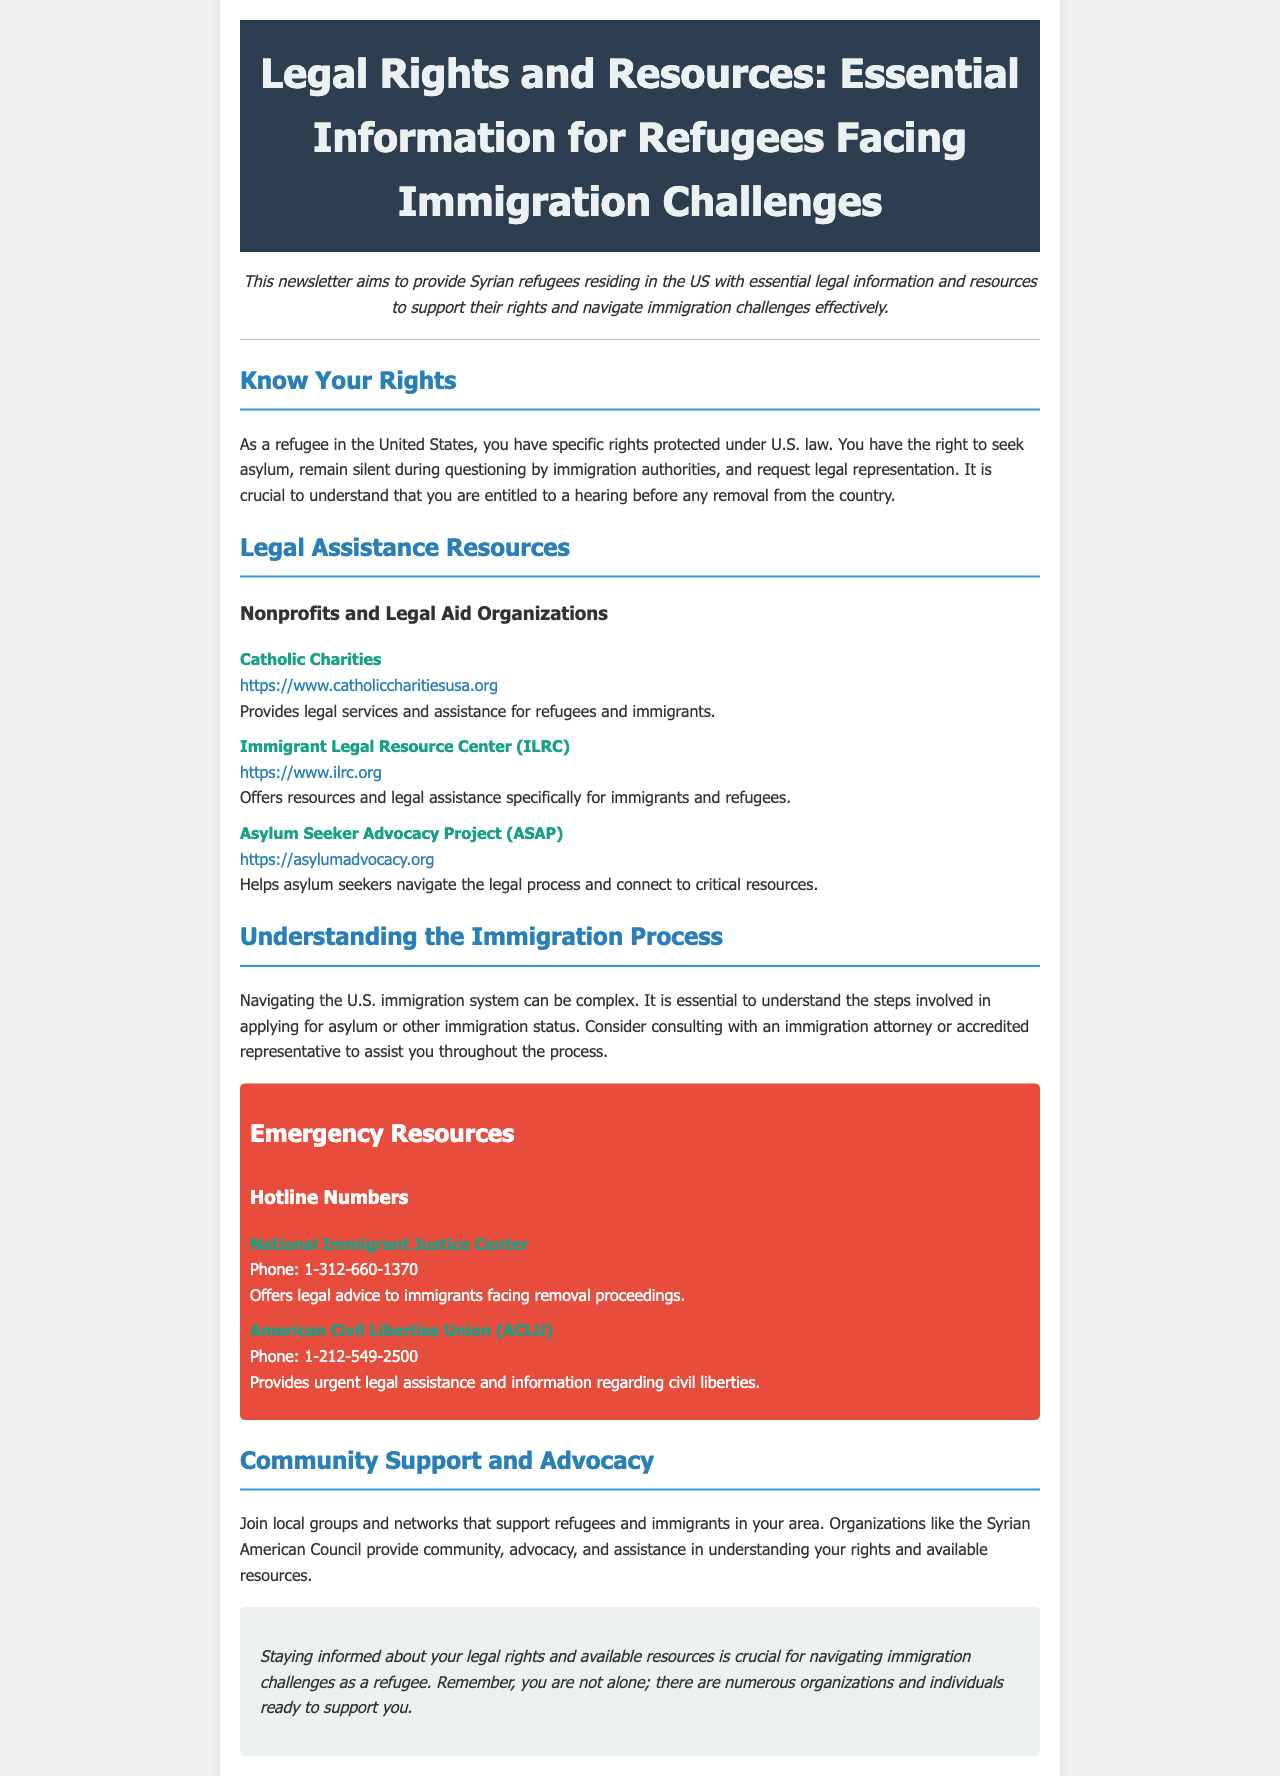what is the title of the newsletter? The title is the main heading found at the top of the document, highlighting the subject focus of the content.
Answer: Legal Rights and Resources: Essential Information for Refugees Facing Immigration Challenges what organization provides legal services for refugees and immigrants? This information is retrieved from the section listing organizations that assist refugees and immigrants in the U.S.
Answer: Catholic Charities what is the phone number for the National Immigrant Justice Center? The phone number can be found in the emergency resources section under hotline numbers.
Answer: 1-312-660-1370 which organization helps asylum seekers navigate the legal process? This question focuses on identifying a specific organization mentioned in the resources section dedicated to asylum seekers.
Answer: Asylum Seeker Advocacy Project (ASAP) what is the main process refugees should understand when navigating the U.S. immigration system? This reasoning question requires understanding the overarching theme in the section about understanding immigration processes.
Answer: Applying for asylum what type of assistance does the ACLU provide? This question pertains to the service offered by the organization mentioned in the emergency resources section.
Answer: Urgent legal assistance how can refugees find support in their local communities? This question addresses the method of finding community support as detailed in the community support and advocacy section.
Answer: Join local groups and networks what is the purpose of the newsletter? This question seeks to summarize the intent behind the creation of the document, as stated in the introduction.
Answer: Provide essential legal information and resources for Syrian refugees 